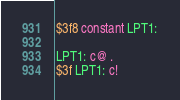Convert code to text. <code><loc_0><loc_0><loc_500><loc_500><_Forth_>$3f8 constant LPT1:

LPT1: c@ .
$3f LPT1: c!
</code> 